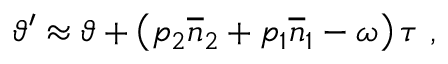<formula> <loc_0><loc_0><loc_500><loc_500>\vartheta ^ { \prime } \approx \vartheta + \left ( p _ { 2 } \overline { n } _ { 2 } + p _ { 1 } \overline { n } _ { 1 } - \omega \right ) \tau \ ,</formula> 